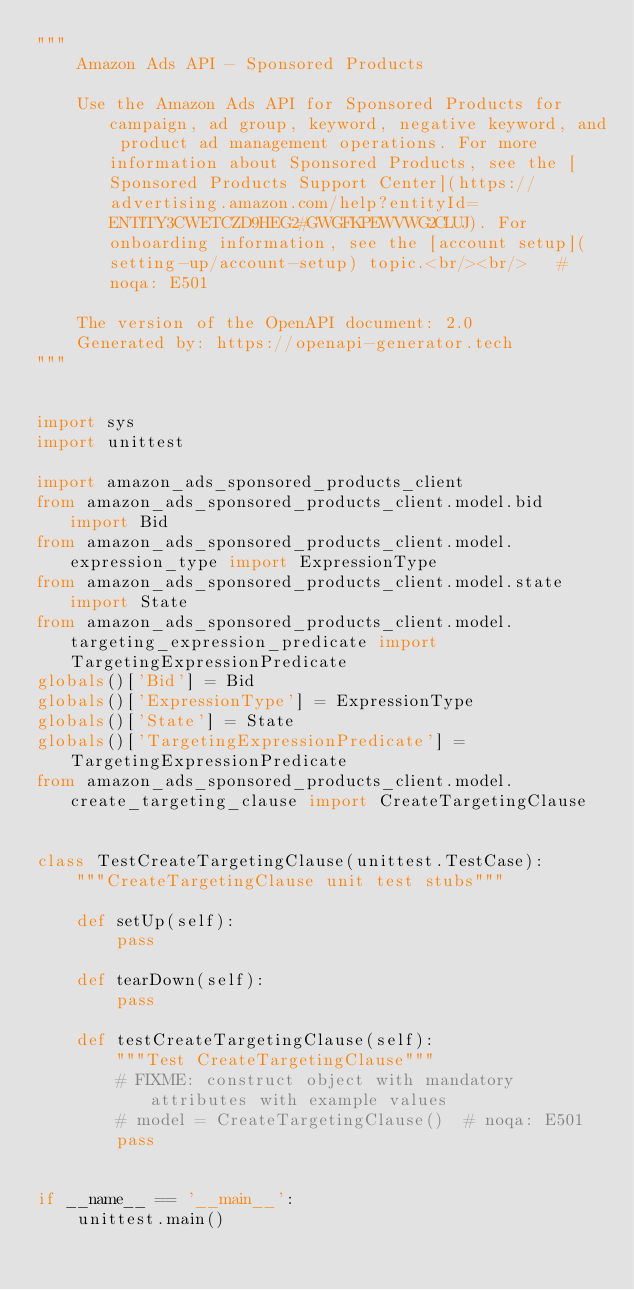Convert code to text. <code><loc_0><loc_0><loc_500><loc_500><_Python_>"""
    Amazon Ads API - Sponsored Products

    Use the Amazon Ads API for Sponsored Products for campaign, ad group, keyword, negative keyword, and product ad management operations. For more information about Sponsored Products, see the [Sponsored Products Support Center](https://advertising.amazon.com/help?entityId=ENTITY3CWETCZD9HEG2#GWGFKPEWVWG2CLUJ). For onboarding information, see the [account setup](setting-up/account-setup) topic.<br/><br/>   # noqa: E501

    The version of the OpenAPI document: 2.0
    Generated by: https://openapi-generator.tech
"""


import sys
import unittest

import amazon_ads_sponsored_products_client
from amazon_ads_sponsored_products_client.model.bid import Bid
from amazon_ads_sponsored_products_client.model.expression_type import ExpressionType
from amazon_ads_sponsored_products_client.model.state import State
from amazon_ads_sponsored_products_client.model.targeting_expression_predicate import TargetingExpressionPredicate
globals()['Bid'] = Bid
globals()['ExpressionType'] = ExpressionType
globals()['State'] = State
globals()['TargetingExpressionPredicate'] = TargetingExpressionPredicate
from amazon_ads_sponsored_products_client.model.create_targeting_clause import CreateTargetingClause


class TestCreateTargetingClause(unittest.TestCase):
    """CreateTargetingClause unit test stubs"""

    def setUp(self):
        pass

    def tearDown(self):
        pass

    def testCreateTargetingClause(self):
        """Test CreateTargetingClause"""
        # FIXME: construct object with mandatory attributes with example values
        # model = CreateTargetingClause()  # noqa: E501
        pass


if __name__ == '__main__':
    unittest.main()
</code> 